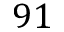<formula> <loc_0><loc_0><loc_500><loc_500>9 1</formula> 